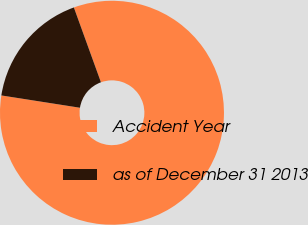Convert chart. <chart><loc_0><loc_0><loc_500><loc_500><pie_chart><fcel>Accident Year<fcel>as of December 31 2013<nl><fcel>83.0%<fcel>17.0%<nl></chart> 